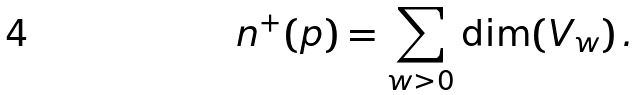<formula> <loc_0><loc_0><loc_500><loc_500>n ^ { + } ( p ) = \sum _ { w > 0 } \dim ( V _ { w } ) \, .</formula> 